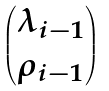Convert formula to latex. <formula><loc_0><loc_0><loc_500><loc_500>\begin{pmatrix} \lambda _ { i - 1 } \\ \rho _ { i - 1 } \end{pmatrix}</formula> 